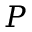<formula> <loc_0><loc_0><loc_500><loc_500>P</formula> 